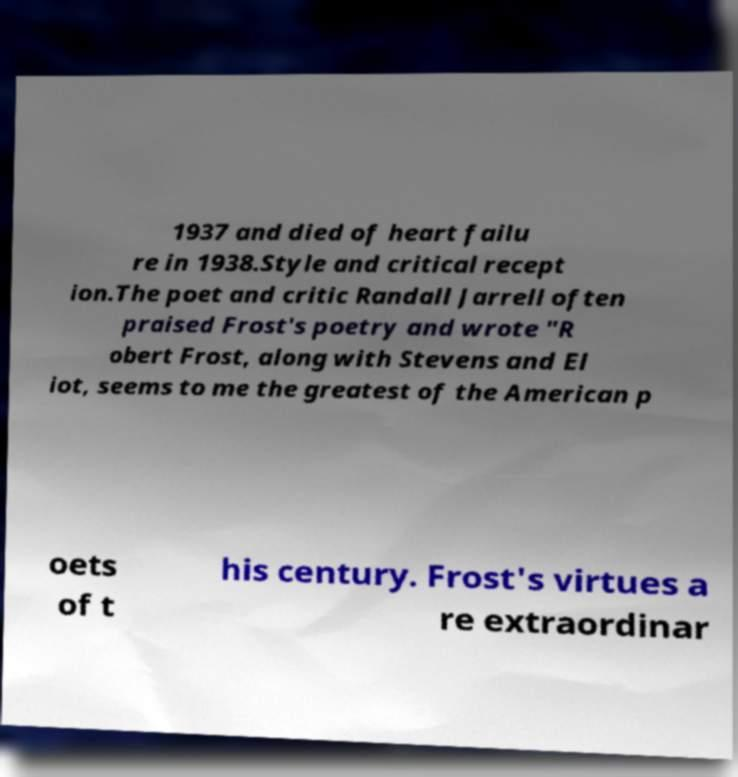Can you accurately transcribe the text from the provided image for me? 1937 and died of heart failu re in 1938.Style and critical recept ion.The poet and critic Randall Jarrell often praised Frost's poetry and wrote "R obert Frost, along with Stevens and El iot, seems to me the greatest of the American p oets of t his century. Frost's virtues a re extraordinar 